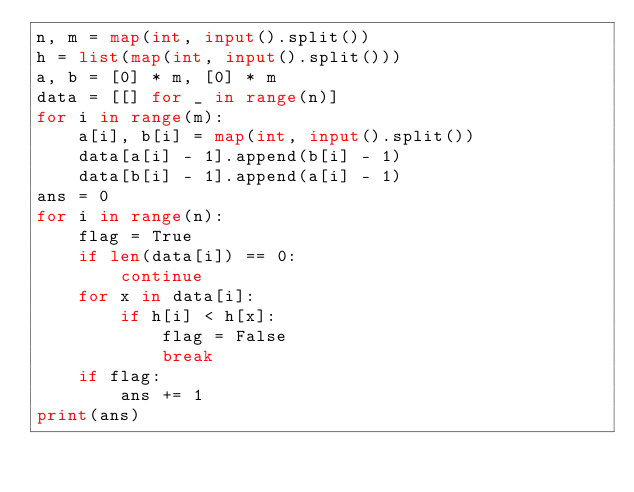Convert code to text. <code><loc_0><loc_0><loc_500><loc_500><_Python_>n, m = map(int, input().split())
h = list(map(int, input().split()))
a, b = [0] * m, [0] * m
data = [[] for _ in range(n)]
for i in range(m):
    a[i], b[i] = map(int, input().split())
    data[a[i] - 1].append(b[i] - 1)
    data[b[i] - 1].append(a[i] - 1)
ans = 0
for i in range(n):
    flag = True
    if len(data[i]) == 0:
        continue 
    for x in data[i]:
        if h[i] < h[x]:
            flag = False
            break
    if flag:
        ans += 1
print(ans)</code> 